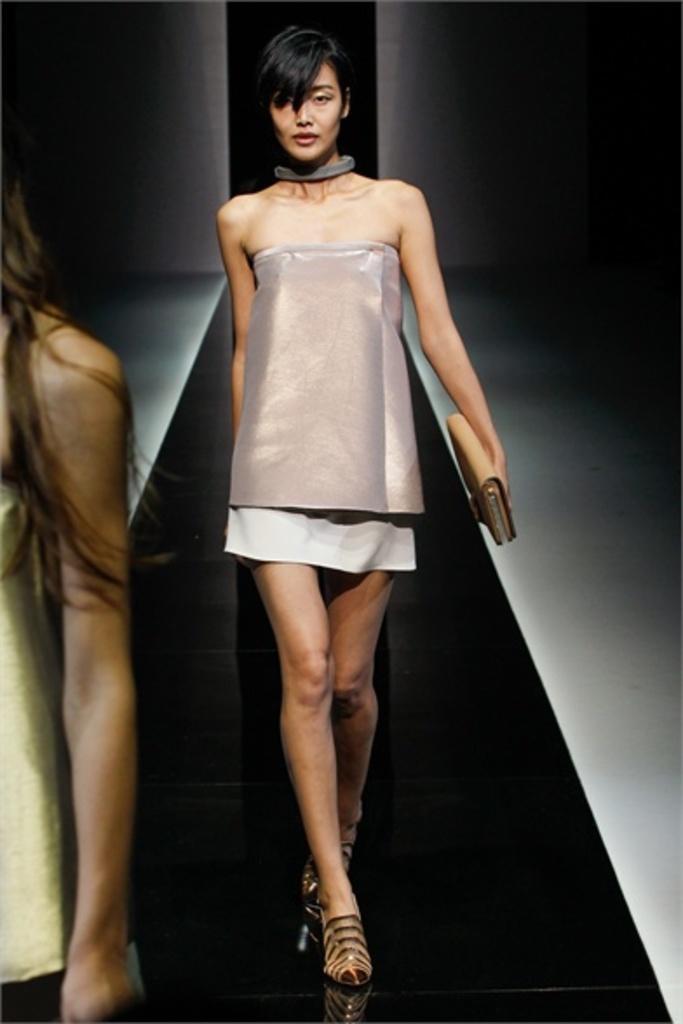Describe this image in one or two sentences. In front of the image there is a person. Behind her there is another person walking on the floor by holding the wallet. In the background of the image there is a wall. 